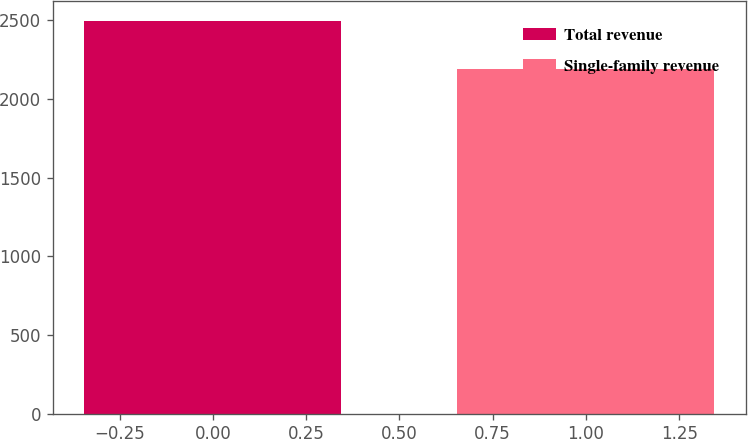Convert chart to OTSL. <chart><loc_0><loc_0><loc_500><loc_500><bar_chart><fcel>Total revenue<fcel>Single-family revenue<nl><fcel>2495<fcel>2193<nl></chart> 